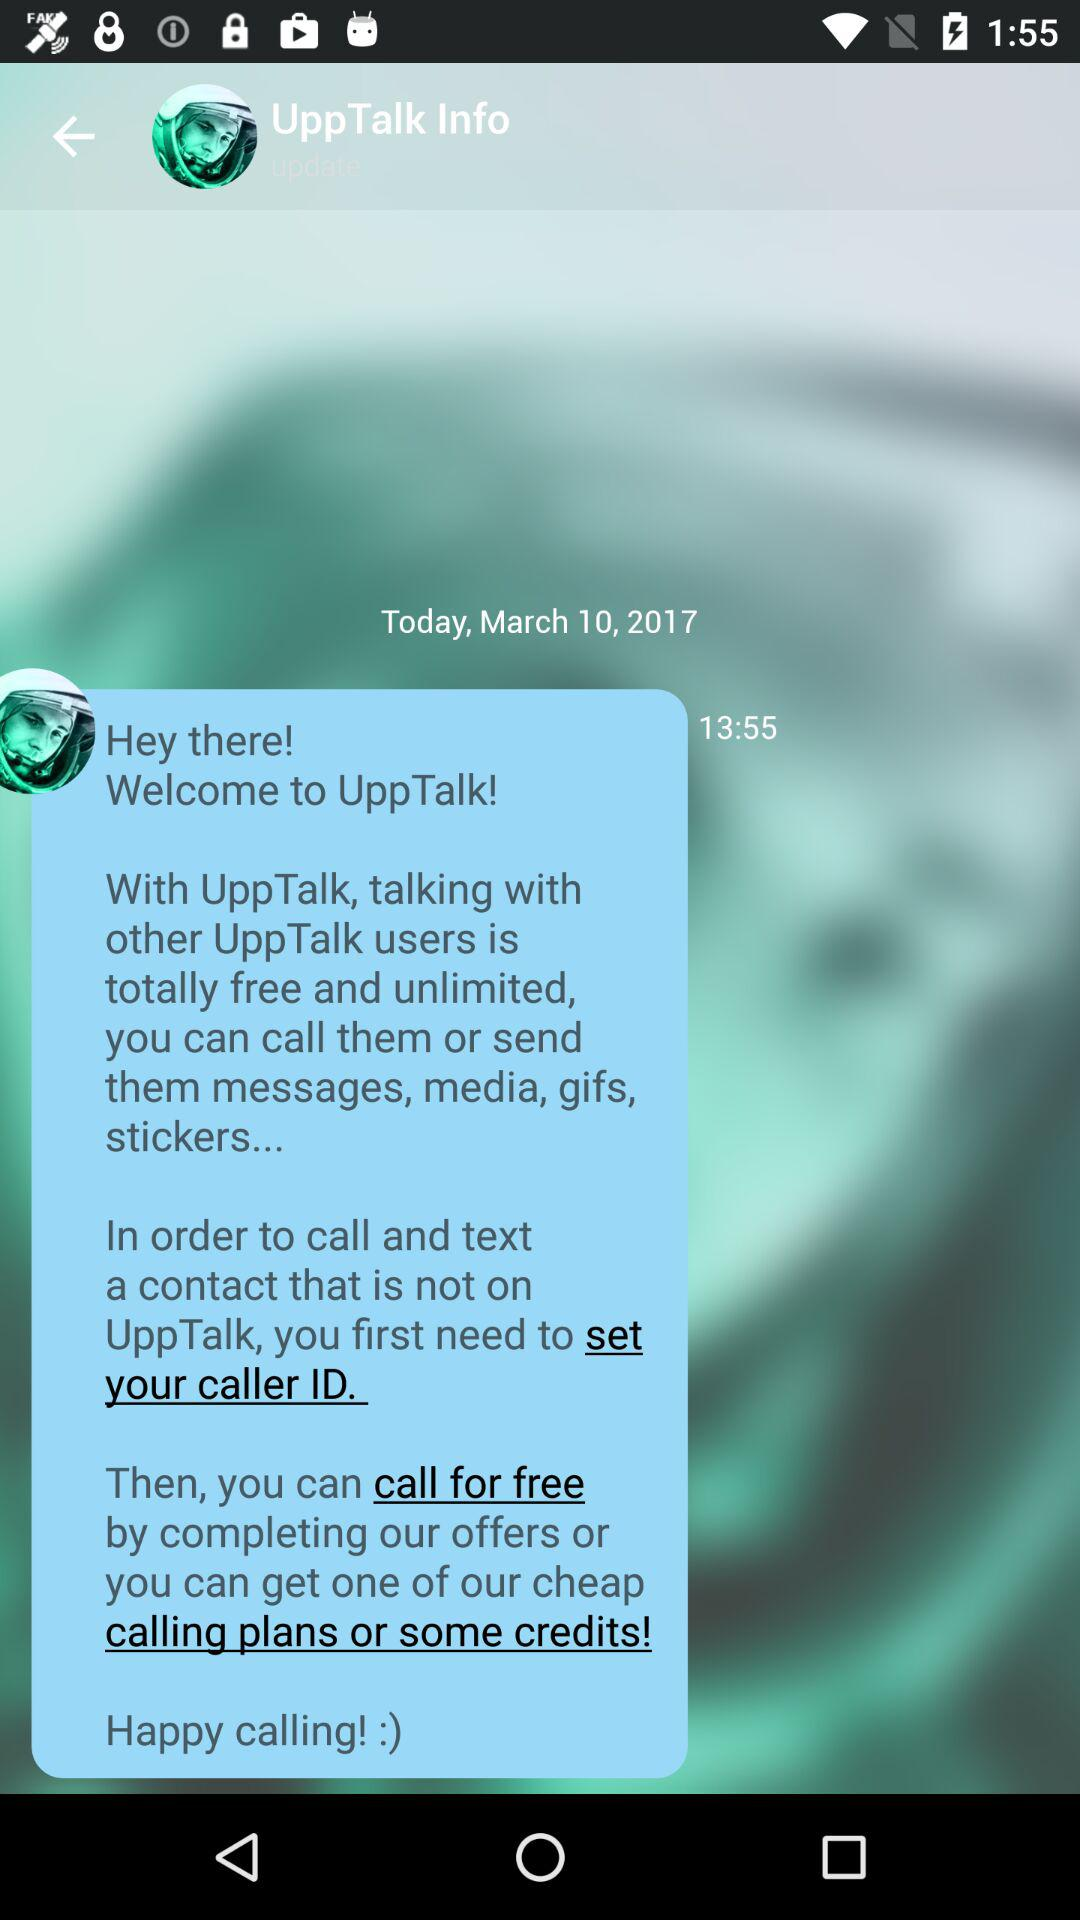Which option is selected?
When the provided information is insufficient, respond with <no answer>. <no answer> 